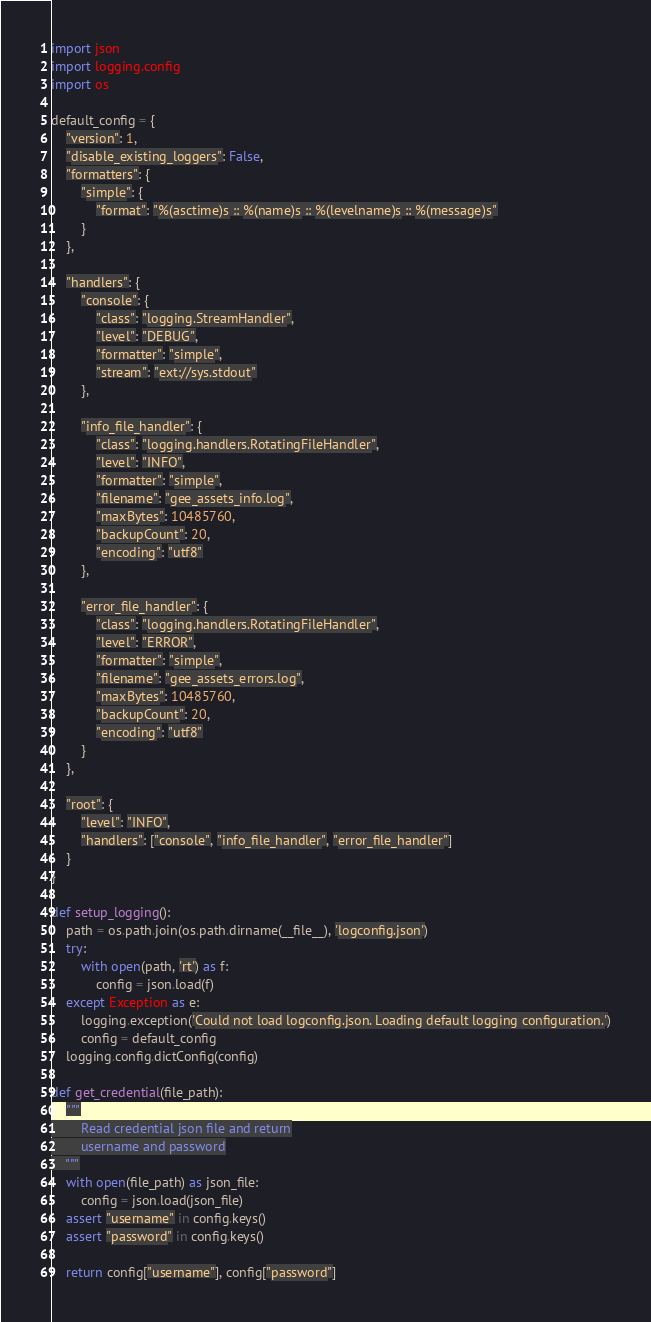<code> <loc_0><loc_0><loc_500><loc_500><_Python_>import json
import logging.config
import os

default_config = {
    "version": 1,
    "disable_existing_loggers": False,
    "formatters": {
        "simple": {
            "format": "%(asctime)s :: %(name)s :: %(levelname)s :: %(message)s"
        }
    },

    "handlers": {
        "console": {
            "class": "logging.StreamHandler",
            "level": "DEBUG",
            "formatter": "simple",
            "stream": "ext://sys.stdout"
        },

        "info_file_handler": {
            "class": "logging.handlers.RotatingFileHandler",
            "level": "INFO",
            "formatter": "simple",
            "filename": "gee_assets_info.log",
            "maxBytes": 10485760,
            "backupCount": 20,
            "encoding": "utf8"
        },

        "error_file_handler": {
            "class": "logging.handlers.RotatingFileHandler",
            "level": "ERROR",
            "formatter": "simple",
            "filename": "gee_assets_errors.log",
            "maxBytes": 10485760,
            "backupCount": 20,
            "encoding": "utf8"
        }
    },

    "root": {
        "level": "INFO",
        "handlers": ["console", "info_file_handler", "error_file_handler"]
    }
}

def setup_logging():
    path = os.path.join(os.path.dirname(__file__), 'logconfig.json')
    try:
        with open(path, 'rt') as f:
            config = json.load(f)
    except Exception as e:
        logging.exception('Could not load logconfig.json. Loading default logging configuration.')
        config = default_config
    logging.config.dictConfig(config)

def get_credential(file_path):
    """
        Read credential json file and return
        username and password
    """
    with open(file_path) as json_file:
        config = json.load(json_file)
    assert "username" in config.keys()
    assert "password" in config.keys()

    return config["username"], config["password"]

</code> 